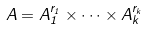<formula> <loc_0><loc_0><loc_500><loc_500>A = A _ { 1 } ^ { r _ { 1 } } \times \dots \times A _ { k } ^ { r _ { k } }</formula> 